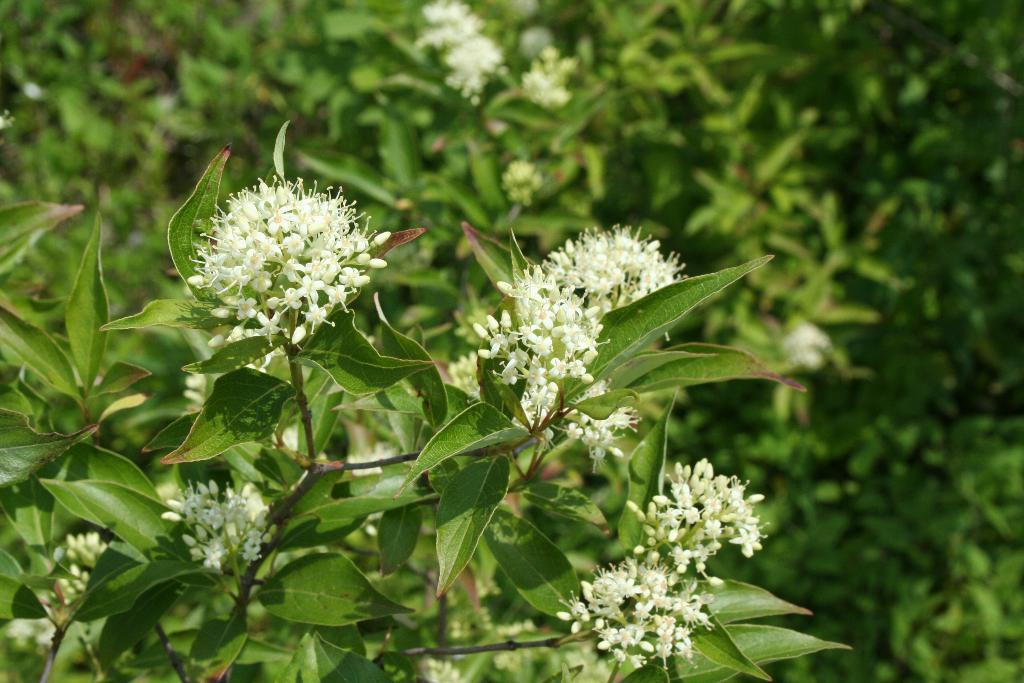What type of living organisms can be seen in the image? There are flowers and plants in the image. Can you describe the plants in the image? The plants in the image are not specified, but they are present alongside the flowers. What type of seashore can be seen in the image? There is no seashore present in the image; it features flowers and plants. How does the back of the image contribute to the overall composition? The back of the image is not visible or relevant to the image, as it only features flowers and plants. 